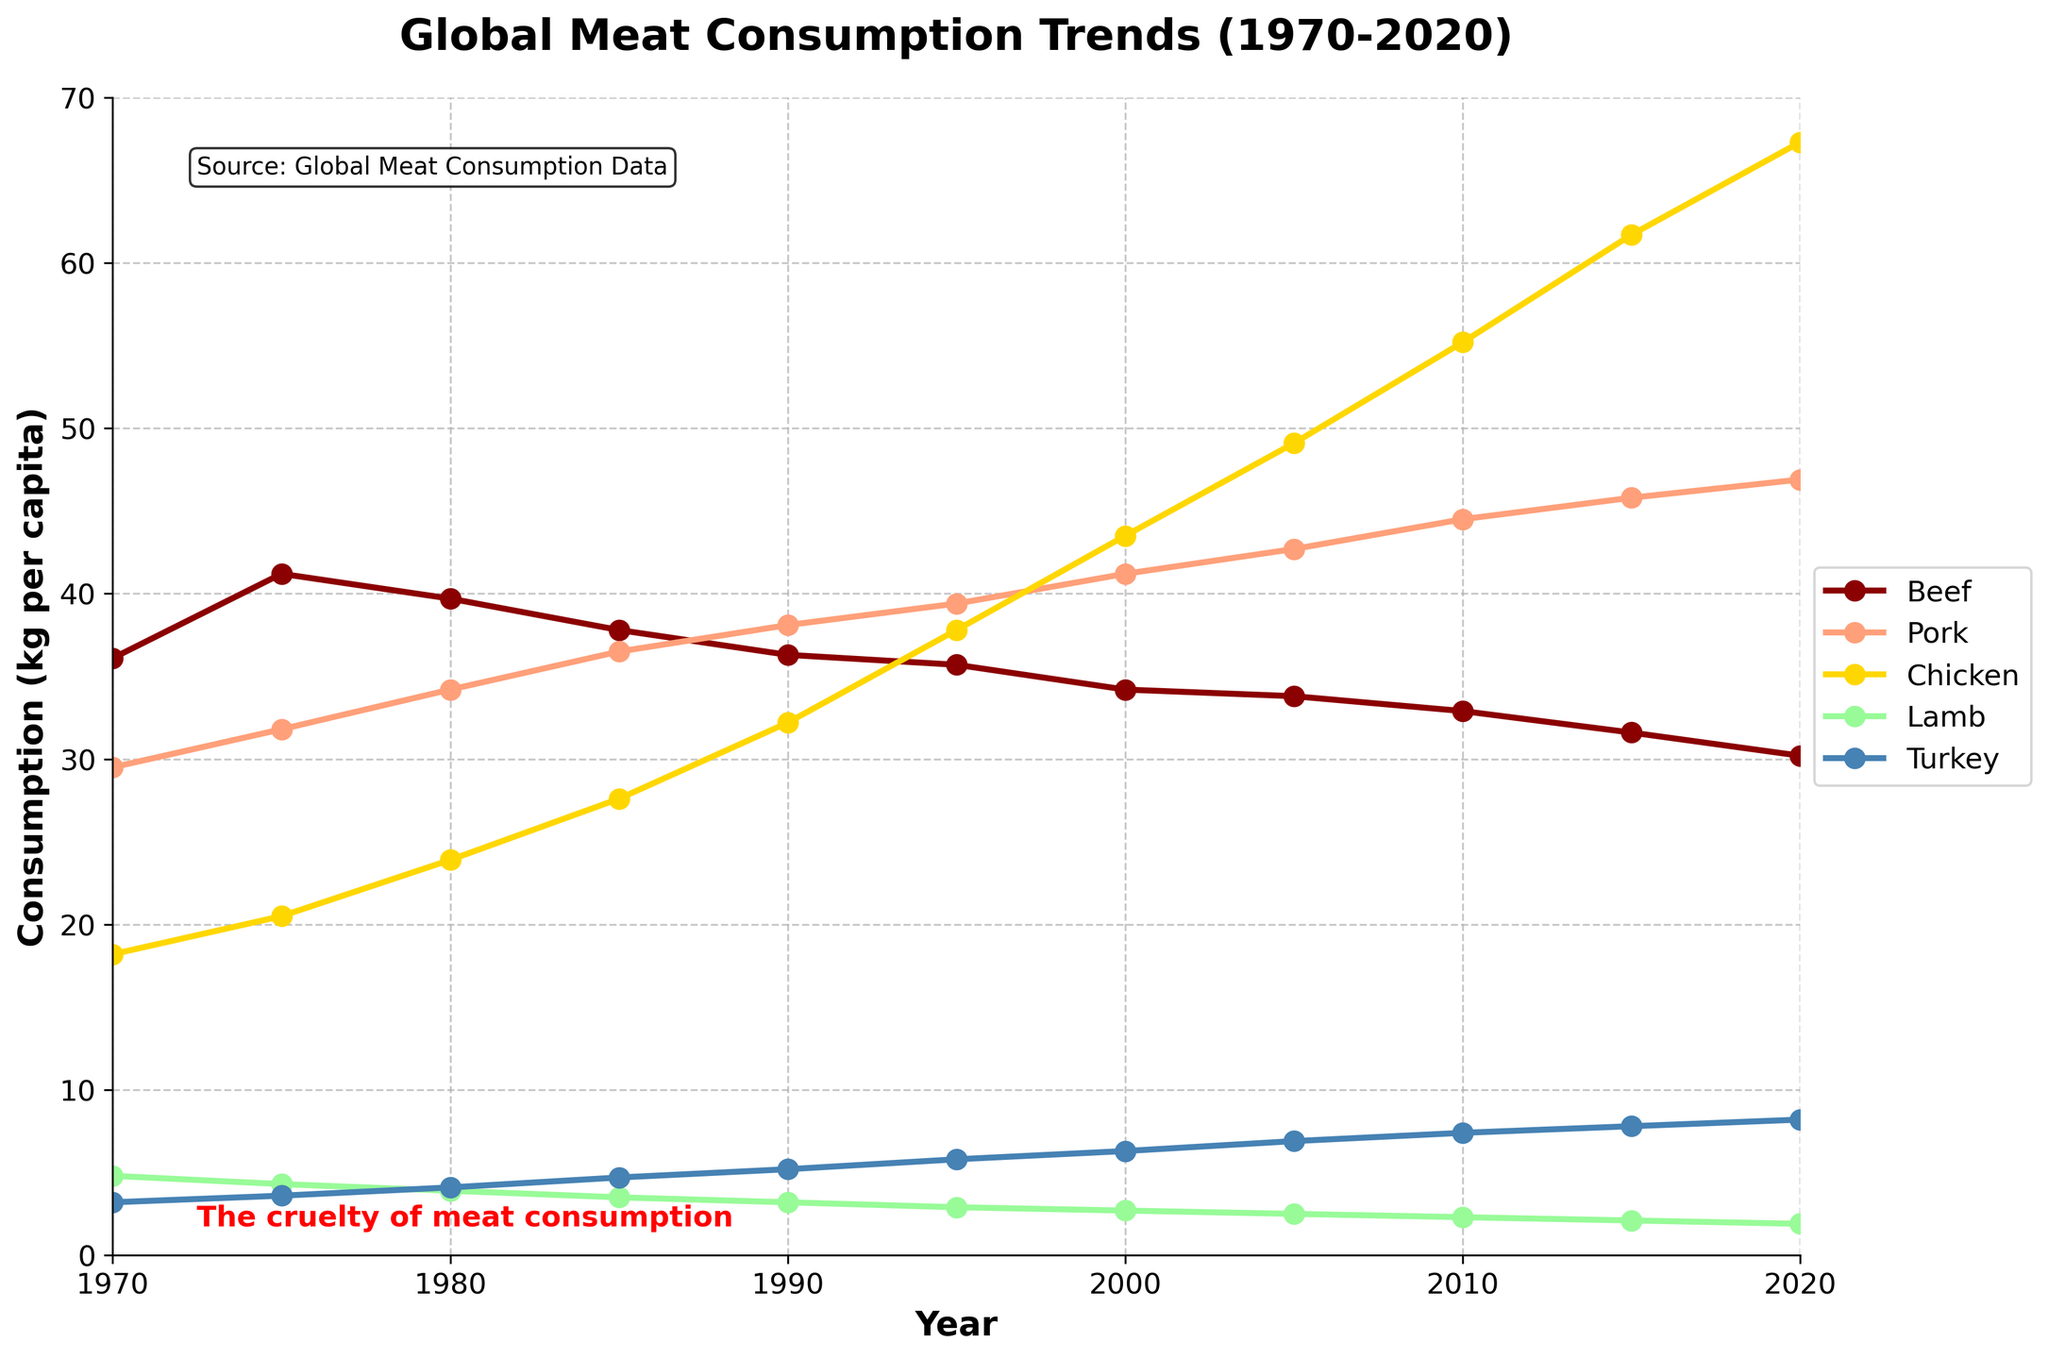What was the trend of chicken consumption from 1970 to 2020? To understand the trend, look at the line representing chicken consumption over the years on the plot. It starts at a relatively lower level (18.2 kg per capita) in 1970 and steadily increases each subsequent year until it reaches 67.3 kg per capita in 2020.
Answer: Increasing Which year had the highest consumption of pork? To find the highest consumption of pork, find the peak value for the pork line on the plot and note its corresponding year. The highest point on the pork line is around 2015 and 2020, with values close to 45.8-46.9 kg per capita.
Answer: 2020 In which year did turkey consumption surpass lamb consumption? Compare the lines of turkey and lamb. Turkey consumption surpasses lamb consumption where the turkey line goes above the lamb line. This crossover happens around the year 1990.
Answer: 1990 By how much did beef consumption decline from its peak in 1975 to 2020? Find the value of beef consumption in 1975 and 2020 and subtract the latter from the former. Beef consumption decreased from 41.2 kg per capita in 1975 to 30.2 kg per capita in 2020. The decline is 41.2 - 30.2 = 11 kg per capita.
Answer: 11 kg per capita Which type of meat saw the largest increase in consumption from 1970 to 2020? To find which meat saw the largest increase, compare the change in consumption for each type of meat from 1970 to 2020. Chicken's consumption increased the most from 18.2 kg per capita in 1970 to 67.3 kg per capita in 2020, which is an increase of 67.3 - 18.2 = 49.1 kg per capita.
Answer: Chicken How many types of meat have consistently increasing trends from 1970 to 2020? Observe the trend lines for whether they consistently rise from 1970 to 2020. Chicken and turkey show a consistent increase over time. This totals two types of meat.
Answer: 2 Compare the average consumption of beef and pork over the years. Which is higher? Calculate the average for both types over the given years. Summing the beef values (36.1 + 41.2 + 39.7 + 37.8 + 36.3 + 35.7 + 34.2 + 33.8 + 32.9 + 31.6 + 30.2) & dividing by 11 results in approximately 35.1. Summing the pork values (29.5 + 31.8 + 34.2 + 36.5 + 38.1 + 39.4 + 41.2 + 42.7 + 44.5 + 45.8 + 46.9), & dividing by 11 results in approximately 38.7. Pork has a higher average consumption.
Answer: Pork 